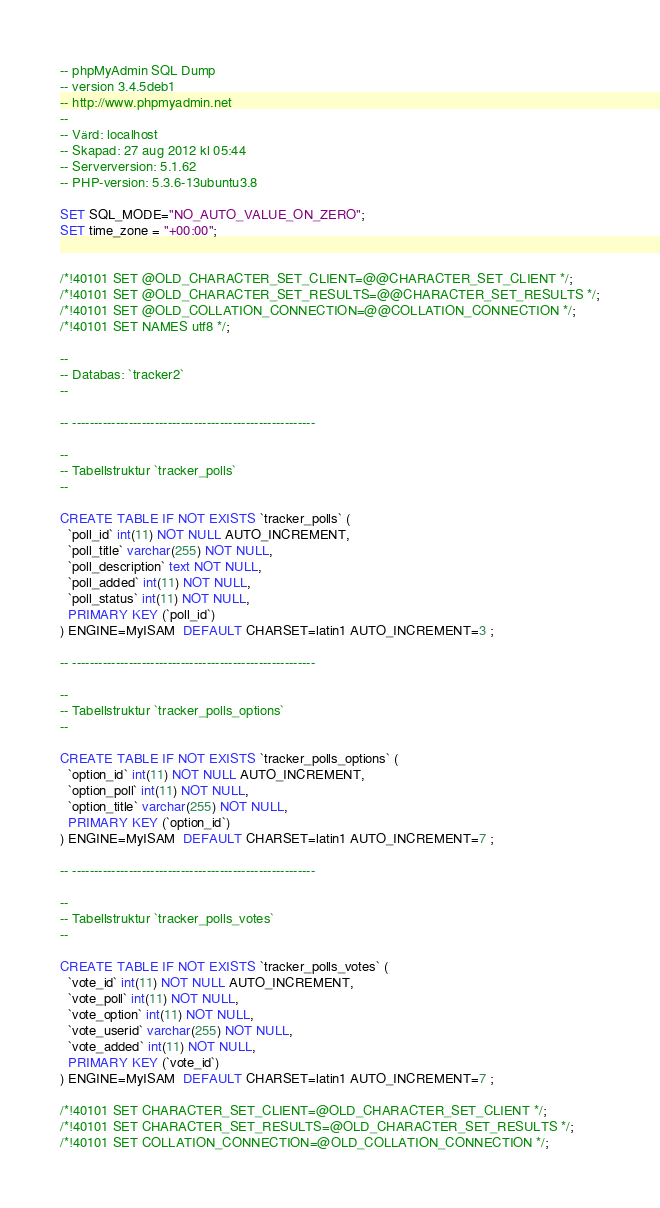Convert code to text. <code><loc_0><loc_0><loc_500><loc_500><_SQL_>-- phpMyAdmin SQL Dump
-- version 3.4.5deb1
-- http://www.phpmyadmin.net
--
-- Värd: localhost
-- Skapad: 27 aug 2012 kl 05:44
-- Serverversion: 5.1.62
-- PHP-version: 5.3.6-13ubuntu3.8

SET SQL_MODE="NO_AUTO_VALUE_ON_ZERO";
SET time_zone = "+00:00";


/*!40101 SET @OLD_CHARACTER_SET_CLIENT=@@CHARACTER_SET_CLIENT */;
/*!40101 SET @OLD_CHARACTER_SET_RESULTS=@@CHARACTER_SET_RESULTS */;
/*!40101 SET @OLD_COLLATION_CONNECTION=@@COLLATION_CONNECTION */;
/*!40101 SET NAMES utf8 */;

--
-- Databas: `tracker2`
--

-- --------------------------------------------------------

--
-- Tabellstruktur `tracker_polls`
--

CREATE TABLE IF NOT EXISTS `tracker_polls` (
  `poll_id` int(11) NOT NULL AUTO_INCREMENT,
  `poll_title` varchar(255) NOT NULL,
  `poll_description` text NOT NULL,
  `poll_added` int(11) NOT NULL,
  `poll_status` int(11) NOT NULL,
  PRIMARY KEY (`poll_id`)
) ENGINE=MyISAM  DEFAULT CHARSET=latin1 AUTO_INCREMENT=3 ;

-- --------------------------------------------------------

--
-- Tabellstruktur `tracker_polls_options`
--

CREATE TABLE IF NOT EXISTS `tracker_polls_options` (
  `option_id` int(11) NOT NULL AUTO_INCREMENT,
  `option_poll` int(11) NOT NULL,
  `option_title` varchar(255) NOT NULL,
  PRIMARY KEY (`option_id`)
) ENGINE=MyISAM  DEFAULT CHARSET=latin1 AUTO_INCREMENT=7 ;

-- --------------------------------------------------------

--
-- Tabellstruktur `tracker_polls_votes`
--

CREATE TABLE IF NOT EXISTS `tracker_polls_votes` (
  `vote_id` int(11) NOT NULL AUTO_INCREMENT,
  `vote_poll` int(11) NOT NULL,
  `vote_option` int(11) NOT NULL,
  `vote_userid` varchar(255) NOT NULL,
  `vote_added` int(11) NOT NULL,
  PRIMARY KEY (`vote_id`)
) ENGINE=MyISAM  DEFAULT CHARSET=latin1 AUTO_INCREMENT=7 ;

/*!40101 SET CHARACTER_SET_CLIENT=@OLD_CHARACTER_SET_CLIENT */;
/*!40101 SET CHARACTER_SET_RESULTS=@OLD_CHARACTER_SET_RESULTS */;
/*!40101 SET COLLATION_CONNECTION=@OLD_COLLATION_CONNECTION */;
</code> 